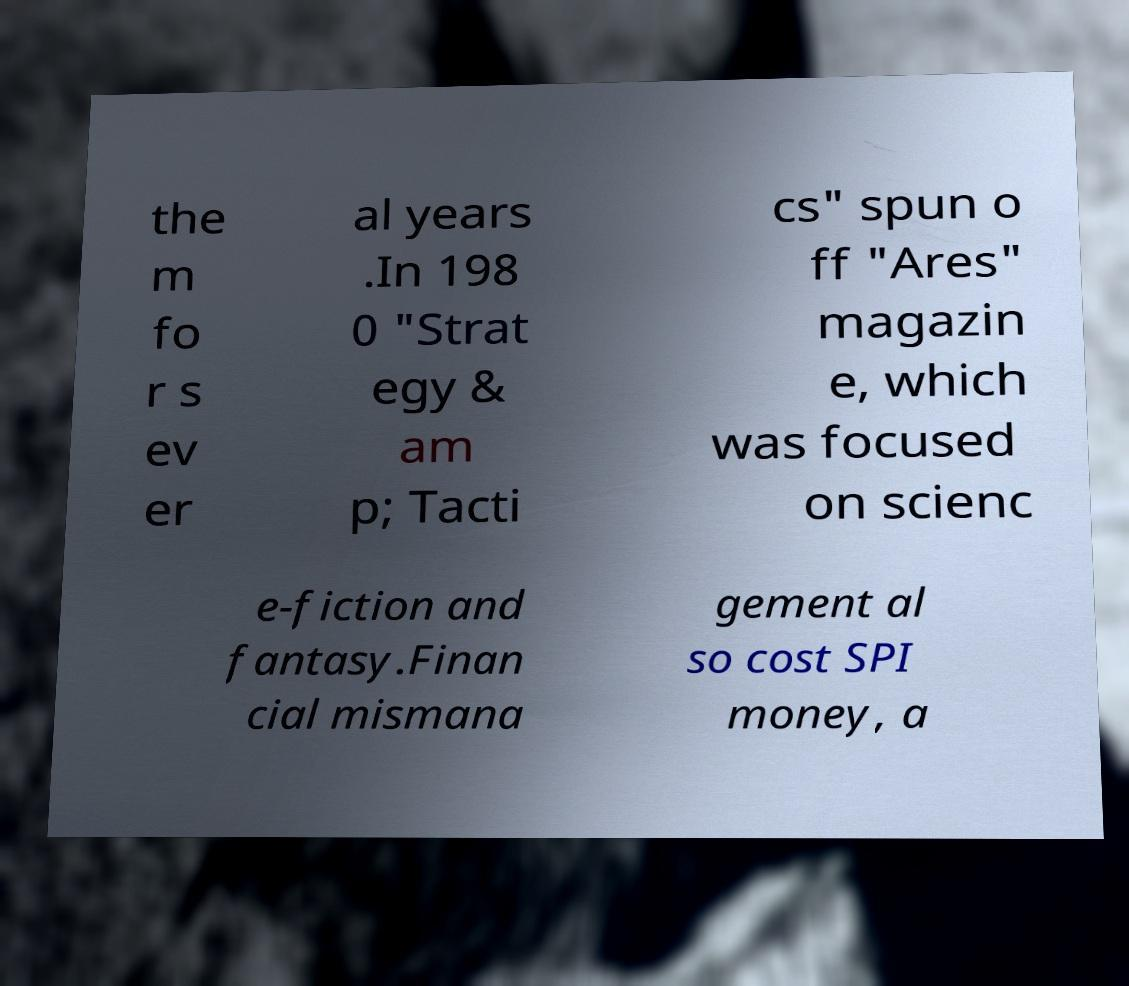Please identify and transcribe the text found in this image. the m fo r s ev er al years .In 198 0 "Strat egy & am p; Tacti cs" spun o ff "Ares" magazin e, which was focused on scienc e-fiction and fantasy.Finan cial mismana gement al so cost SPI money, a 